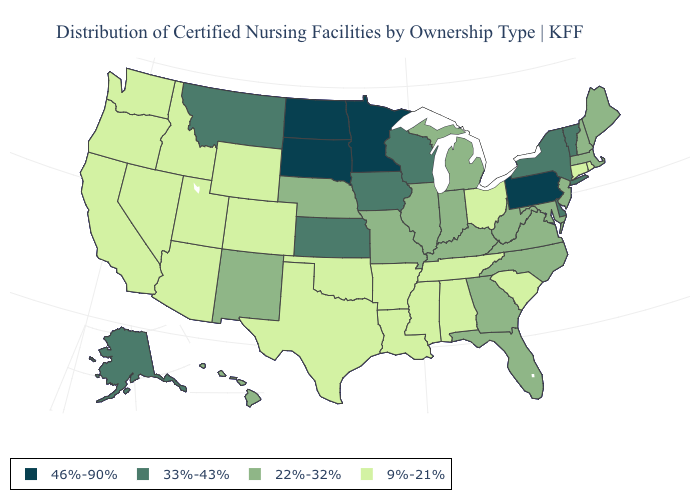Does South Dakota have the highest value in the MidWest?
Answer briefly. Yes. Name the states that have a value in the range 46%-90%?
Short answer required. Minnesota, North Dakota, Pennsylvania, South Dakota. What is the value of Kentucky?
Write a very short answer. 22%-32%. Which states hav the highest value in the South?
Short answer required. Delaware. Does Oregon have the lowest value in the USA?
Quick response, please. Yes. What is the value of New York?
Give a very brief answer. 33%-43%. Name the states that have a value in the range 46%-90%?
Write a very short answer. Minnesota, North Dakota, Pennsylvania, South Dakota. What is the value of Connecticut?
Be succinct. 9%-21%. Does the map have missing data?
Give a very brief answer. No. What is the value of New Hampshire?
Short answer required. 22%-32%. Name the states that have a value in the range 33%-43%?
Answer briefly. Alaska, Delaware, Iowa, Kansas, Montana, New York, Vermont, Wisconsin. What is the lowest value in states that border Michigan?
Give a very brief answer. 9%-21%. What is the lowest value in the USA?
Be succinct. 9%-21%. What is the value of Colorado?
Concise answer only. 9%-21%. 